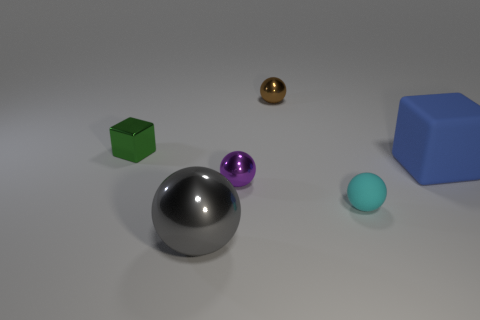Are there more cyan rubber objects than red metal spheres?
Your response must be concise. Yes. How many gray things are in front of the tiny shiny thing on the left side of the thing in front of the cyan thing?
Provide a succinct answer. 1. The large gray object is what shape?
Ensure brevity in your answer.  Sphere. What number of other objects are the same material as the small green thing?
Your answer should be very brief. 3. Do the cyan ball and the brown object have the same size?
Your response must be concise. Yes. What shape is the thing right of the small cyan matte sphere?
Make the answer very short. Cube. There is a tiny object that is in front of the tiny metal thing in front of the tiny green object; what is its color?
Ensure brevity in your answer.  Cyan. Do the tiny thing that is behind the metal block and the small metal object that is in front of the tiny green thing have the same shape?
Your response must be concise. Yes. The green thing that is the same size as the purple sphere is what shape?
Give a very brief answer. Cube. What is the color of the large sphere that is the same material as the purple thing?
Keep it short and to the point. Gray. 